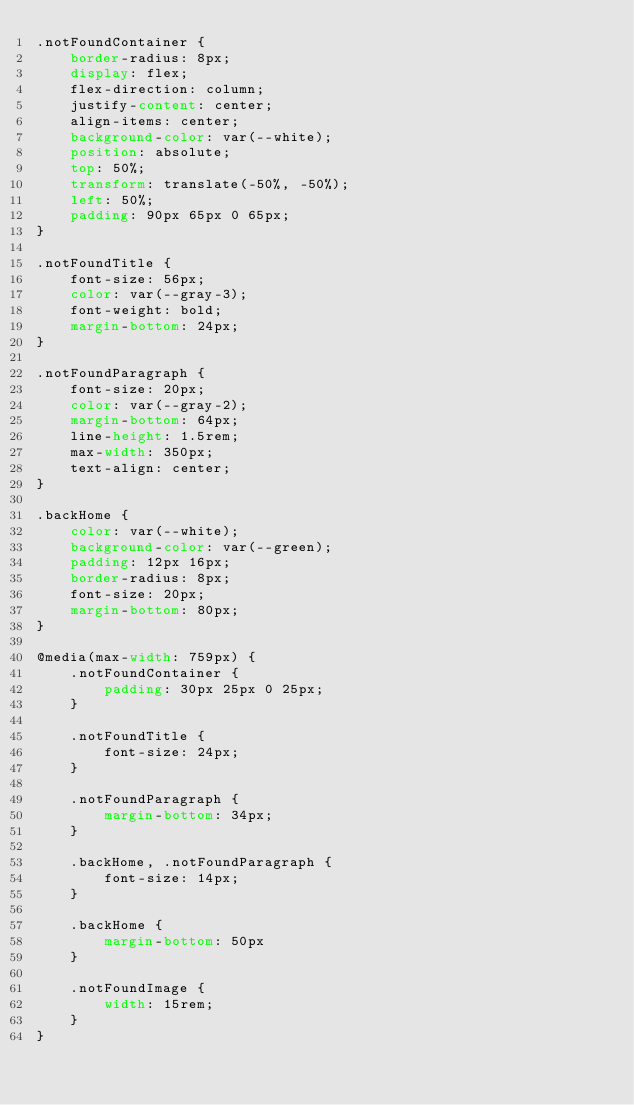<code> <loc_0><loc_0><loc_500><loc_500><_CSS_>.notFoundContainer {
    border-radius: 8px;
    display: flex;
    flex-direction: column;
    justify-content: center;
    align-items: center;
    background-color: var(--white);
    position: absolute;
    top: 50%;
    transform: translate(-50%, -50%);
    left: 50%;
    padding: 90px 65px 0 65px;
}

.notFoundTitle {
    font-size: 56px;
    color: var(--gray-3);
    font-weight: bold;
    margin-bottom: 24px;
}

.notFoundParagraph {
    font-size: 20px;
    color: var(--gray-2);
    margin-bottom: 64px;
    line-height: 1.5rem;
    max-width: 350px;
    text-align: center;
}

.backHome {
    color: var(--white);
    background-color: var(--green);
    padding: 12px 16px;
    border-radius: 8px;
    font-size: 20px;
    margin-bottom: 80px;
}

@media(max-width: 759px) {
    .notFoundContainer {
        padding: 30px 25px 0 25px;
    }

    .notFoundTitle {
        font-size: 24px;
    }

    .notFoundParagraph {
        margin-bottom: 34px;
    }

    .backHome, .notFoundParagraph {
        font-size: 14px;
    }

    .backHome {
        margin-bottom: 50px
    }

    .notFoundImage {
        width: 15rem;
    }
}
</code> 